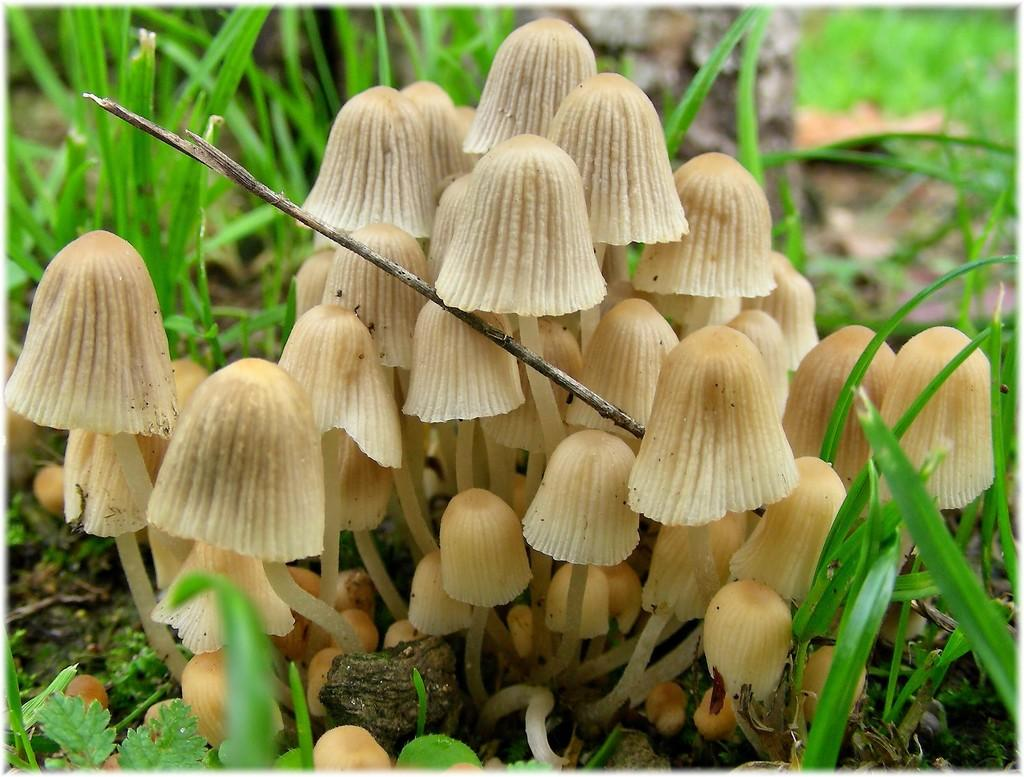What type of fungi can be seen in the image? There are mushrooms in the image. What other types of vegetation are present in the image? There are plants in the image. How many mice can be seen playing with the mushrooms in the image? There are no mice present in the image; it only features mushrooms and plants. What type of weather condition is depicted in the image, such as snow or rain? The image does not depict any weather conditions; it only shows mushrooms and plants. 